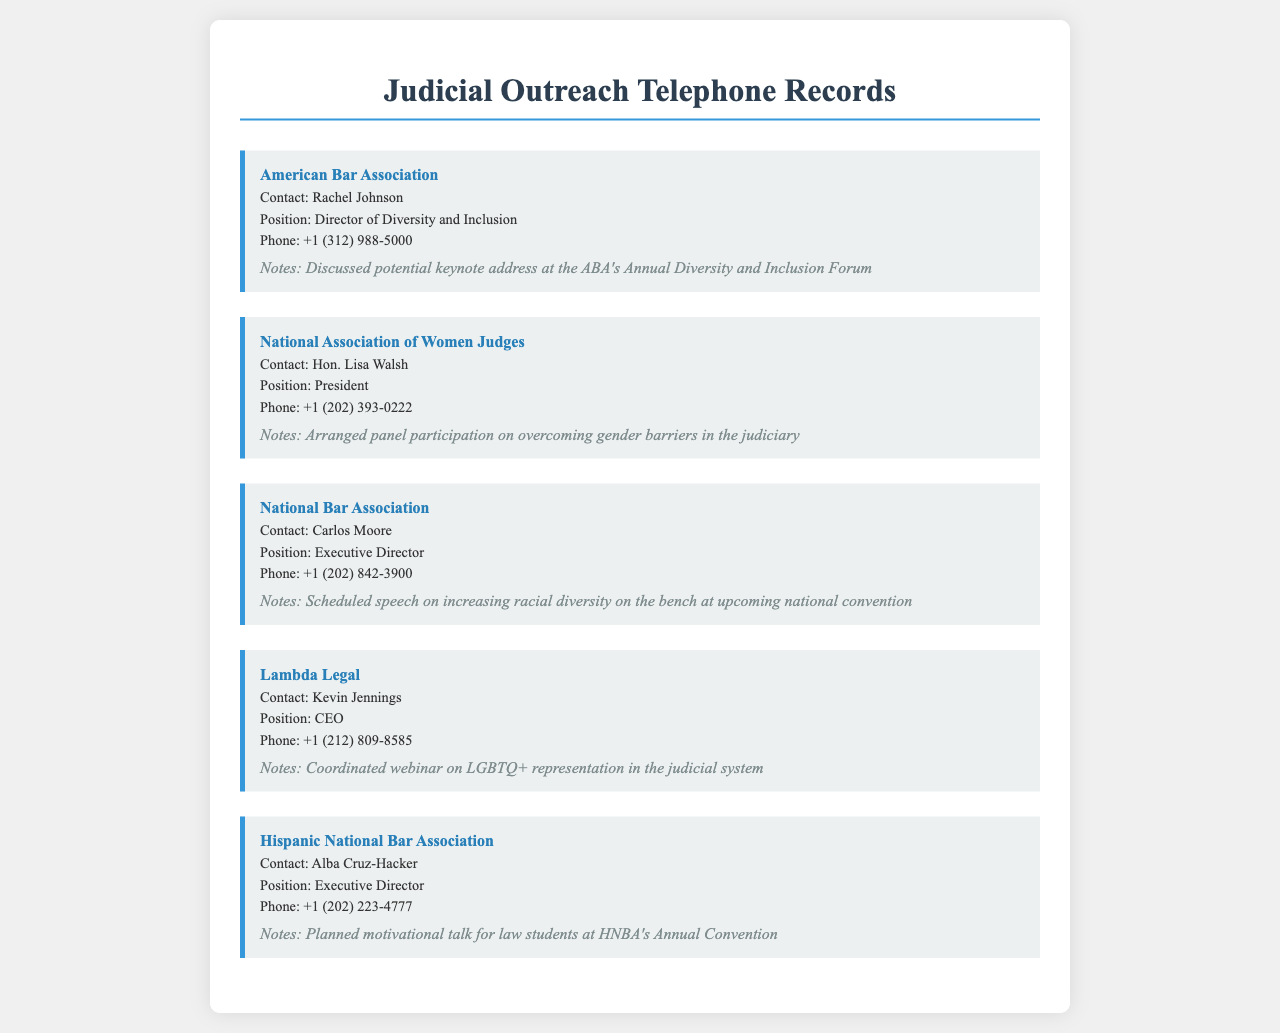What is the organization that Rachel Johnson represents? Rachel Johnson is mentioned as the contact for the American Bar Association in the document.
Answer: American Bar Association Who is the President of the National Association of Women Judges? The document states that Hon. Lisa Walsh holds the position of President at the National Association of Women Judges.
Answer: Hon. Lisa Walsh What event did Carlos Moore schedule a speech for? The document indicates that Carlos Moore scheduled a speech at the upcoming national convention related to increasing racial diversity on the bench.
Answer: Upcoming national convention Which organization is associated with Kevin Jennings? The document identifies Kevin Jennings as the CEO of Lambda Legal.
Answer: Lambda Legal What was discussed with the American Bar Association? The notes indicate a discussion about a potential keynote address at the ABA's Annual Diversity and Inclusion Forum.
Answer: Keynote address at the ABA's Annual Diversity and Inclusion Forum How many organizations are contacted in the records? By counting each listed organization in the document, we find a total of five organizations mentioned.
Answer: Five What type of event is being coordinated by Lambda Legal? The notes indicate that a webinar on LGBTQ+ representation in the judicial system is being coordinated.
Answer: Webinar What is Alba Cruz-Hacker's position? The document specifies that Alba Cruz-Hacker is the Executive Director of the Hispanic National Bar Association.
Answer: Executive Director Which organization is planning a motivational talk for law students? The document mentions that the Hispanic National Bar Association is planning this motivational talk at its Annual Convention.
Answer: Hispanic National Bar Association What does the call record format consist of? The call record format includes the organization, contact, position, phone, and notes as structured sections.
Answer: Organization, contact, position, phone, and notes 